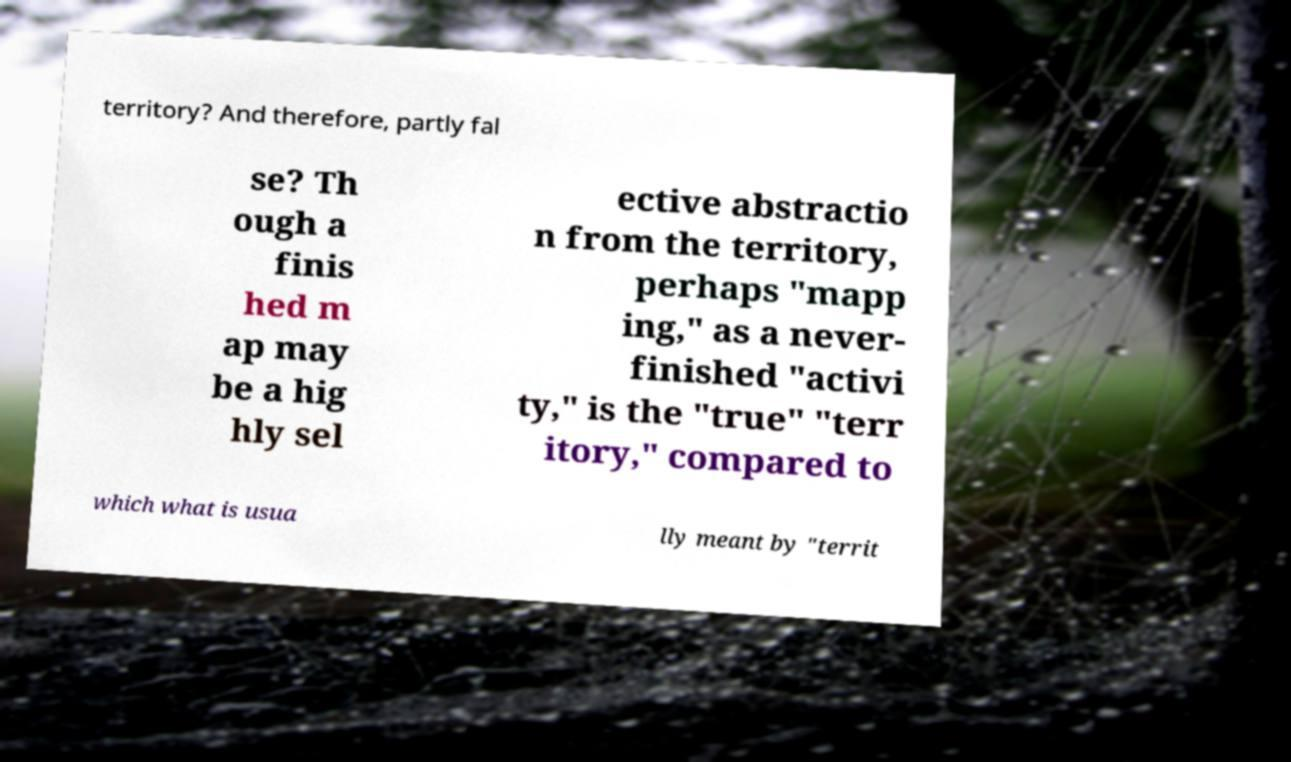For documentation purposes, I need the text within this image transcribed. Could you provide that? territory? And therefore, partly fal se? Th ough a finis hed m ap may be a hig hly sel ective abstractio n from the territory, perhaps "mapp ing," as a never- finished "activi ty," is the "true" "terr itory," compared to which what is usua lly meant by "territ 